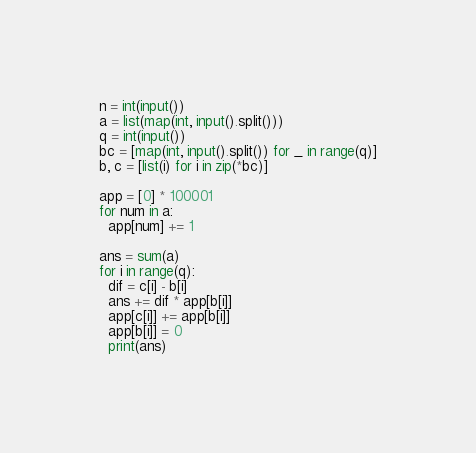<code> <loc_0><loc_0><loc_500><loc_500><_Python_>n = int(input())
a = list(map(int, input().split()))
q = int(input())
bc = [map(int, input().split()) for _ in range(q)]
b, c = [list(i) for i in zip(*bc)]

app = [0] * 100001
for num in a:
  app[num] += 1

ans = sum(a)
for i in range(q):
  dif = c[i] - b[i]
  ans += dif * app[b[i]]
  app[c[i]] += app[b[i]]
  app[b[i]] = 0
  print(ans)</code> 